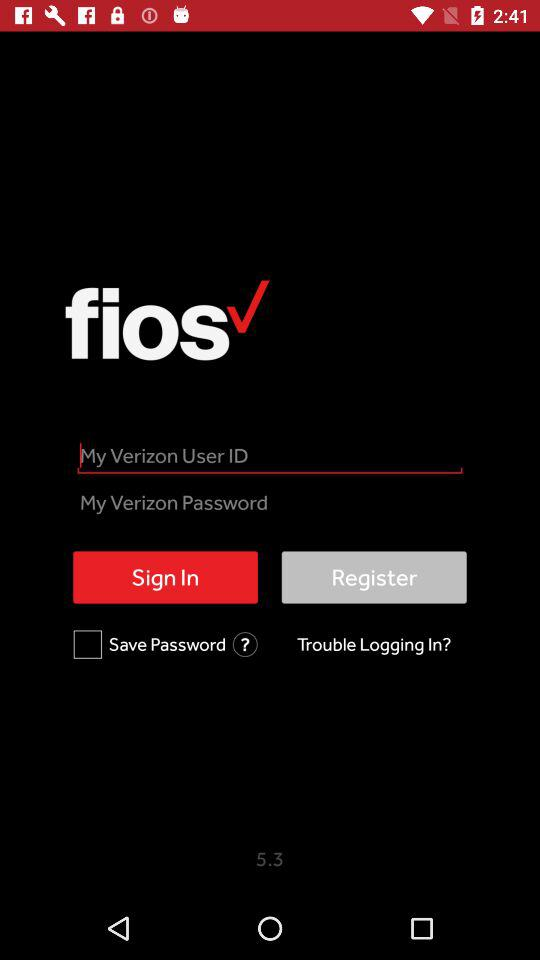What is the name of the application? The application is "Fios". 